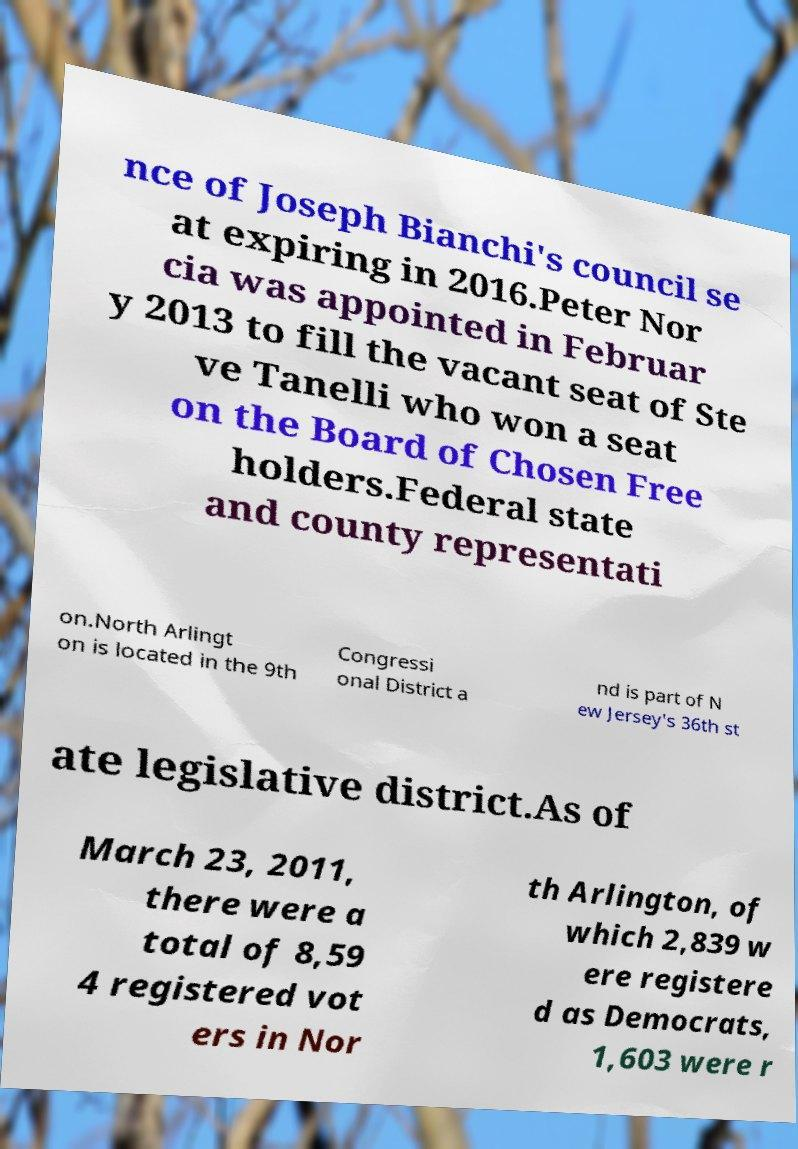Can you read and provide the text displayed in the image?This photo seems to have some interesting text. Can you extract and type it out for me? nce of Joseph Bianchi's council se at expiring in 2016.Peter Nor cia was appointed in Februar y 2013 to fill the vacant seat of Ste ve Tanelli who won a seat on the Board of Chosen Free holders.Federal state and county representati on.North Arlingt on is located in the 9th Congressi onal District a nd is part of N ew Jersey's 36th st ate legislative district.As of March 23, 2011, there were a total of 8,59 4 registered vot ers in Nor th Arlington, of which 2,839 w ere registere d as Democrats, 1,603 were r 